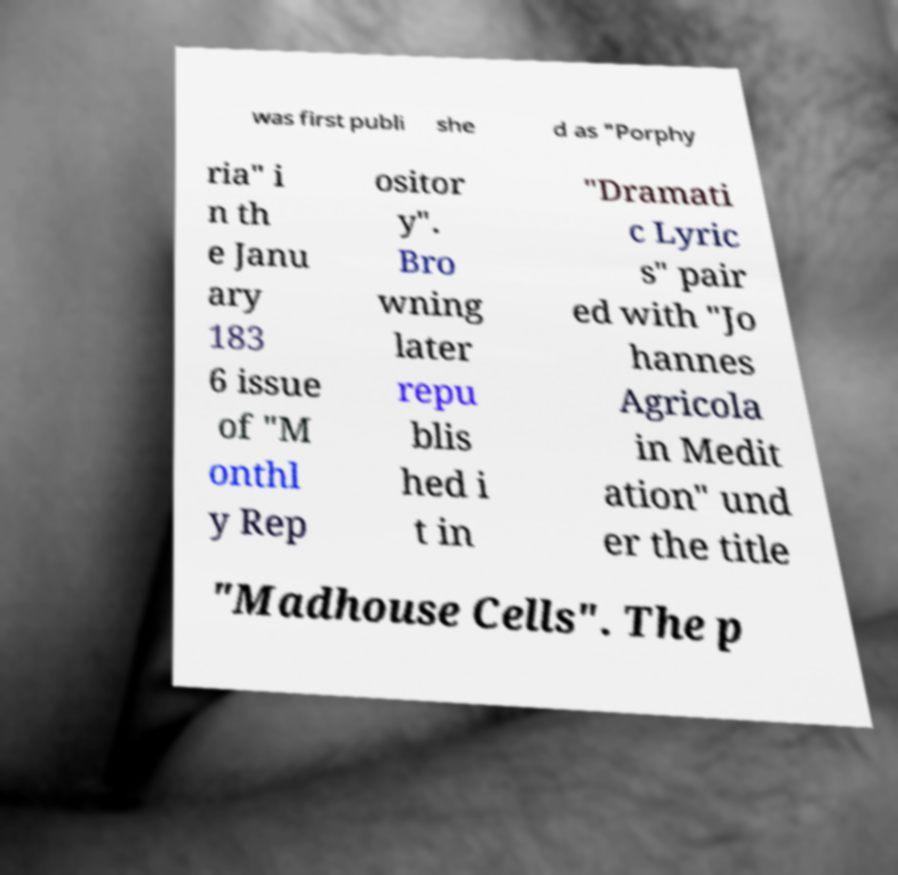Please read and relay the text visible in this image. What does it say? was first publi she d as "Porphy ria" i n th e Janu ary 183 6 issue of "M onthl y Rep ositor y". Bro wning later repu blis hed i t in "Dramati c Lyric s" pair ed with "Jo hannes Agricola in Medit ation" und er the title "Madhouse Cells". The p 